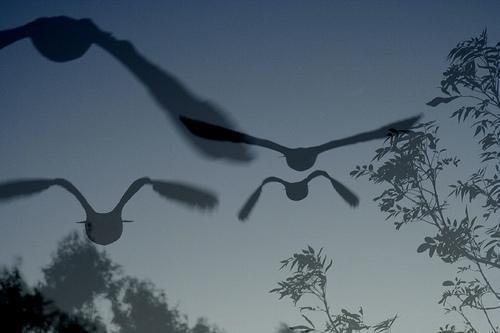How many birds are in the picture?
Give a very brief answer. 4. How many birds can you see?
Give a very brief answer. 4. How many people are to the left of the hydrant?
Give a very brief answer. 0. 